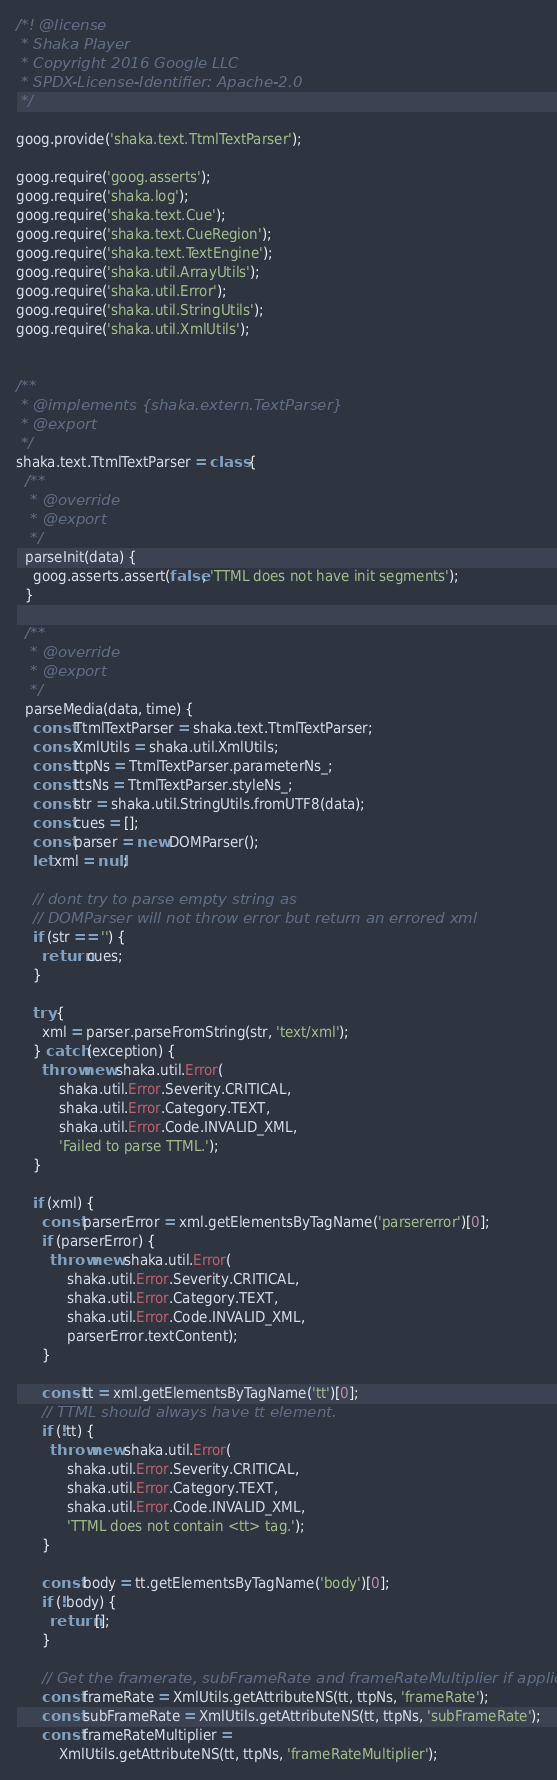Convert code to text. <code><loc_0><loc_0><loc_500><loc_500><_JavaScript_>/*! @license
 * Shaka Player
 * Copyright 2016 Google LLC
 * SPDX-License-Identifier: Apache-2.0
 */

goog.provide('shaka.text.TtmlTextParser');

goog.require('goog.asserts');
goog.require('shaka.log');
goog.require('shaka.text.Cue');
goog.require('shaka.text.CueRegion');
goog.require('shaka.text.TextEngine');
goog.require('shaka.util.ArrayUtils');
goog.require('shaka.util.Error');
goog.require('shaka.util.StringUtils');
goog.require('shaka.util.XmlUtils');


/**
 * @implements {shaka.extern.TextParser}
 * @export
 */
shaka.text.TtmlTextParser = class {
  /**
   * @override
   * @export
   */
  parseInit(data) {
    goog.asserts.assert(false, 'TTML does not have init segments');
  }

  /**
   * @override
   * @export
   */
  parseMedia(data, time) {
    const TtmlTextParser = shaka.text.TtmlTextParser;
    const XmlUtils = shaka.util.XmlUtils;
    const ttpNs = TtmlTextParser.parameterNs_;
    const ttsNs = TtmlTextParser.styleNs_;
    const str = shaka.util.StringUtils.fromUTF8(data);
    const cues = [];
    const parser = new DOMParser();
    let xml = null;

    // dont try to parse empty string as
    // DOMParser will not throw error but return an errored xml
    if (str == '') {
      return cues;
    }

    try {
      xml = parser.parseFromString(str, 'text/xml');
    } catch (exception) {
      throw new shaka.util.Error(
          shaka.util.Error.Severity.CRITICAL,
          shaka.util.Error.Category.TEXT,
          shaka.util.Error.Code.INVALID_XML,
          'Failed to parse TTML.');
    }

    if (xml) {
      const parserError = xml.getElementsByTagName('parsererror')[0];
      if (parserError) {
        throw new shaka.util.Error(
            shaka.util.Error.Severity.CRITICAL,
            shaka.util.Error.Category.TEXT,
            shaka.util.Error.Code.INVALID_XML,
            parserError.textContent);
      }

      const tt = xml.getElementsByTagName('tt')[0];
      // TTML should always have tt element.
      if (!tt) {
        throw new shaka.util.Error(
            shaka.util.Error.Severity.CRITICAL,
            shaka.util.Error.Category.TEXT,
            shaka.util.Error.Code.INVALID_XML,
            'TTML does not contain <tt> tag.');
      }

      const body = tt.getElementsByTagName('body')[0];
      if (!body) {
        return [];
      }

      // Get the framerate, subFrameRate and frameRateMultiplier if applicable.
      const frameRate = XmlUtils.getAttributeNS(tt, ttpNs, 'frameRate');
      const subFrameRate = XmlUtils.getAttributeNS(tt, ttpNs, 'subFrameRate');
      const frameRateMultiplier =
          XmlUtils.getAttributeNS(tt, ttpNs, 'frameRateMultiplier');</code> 